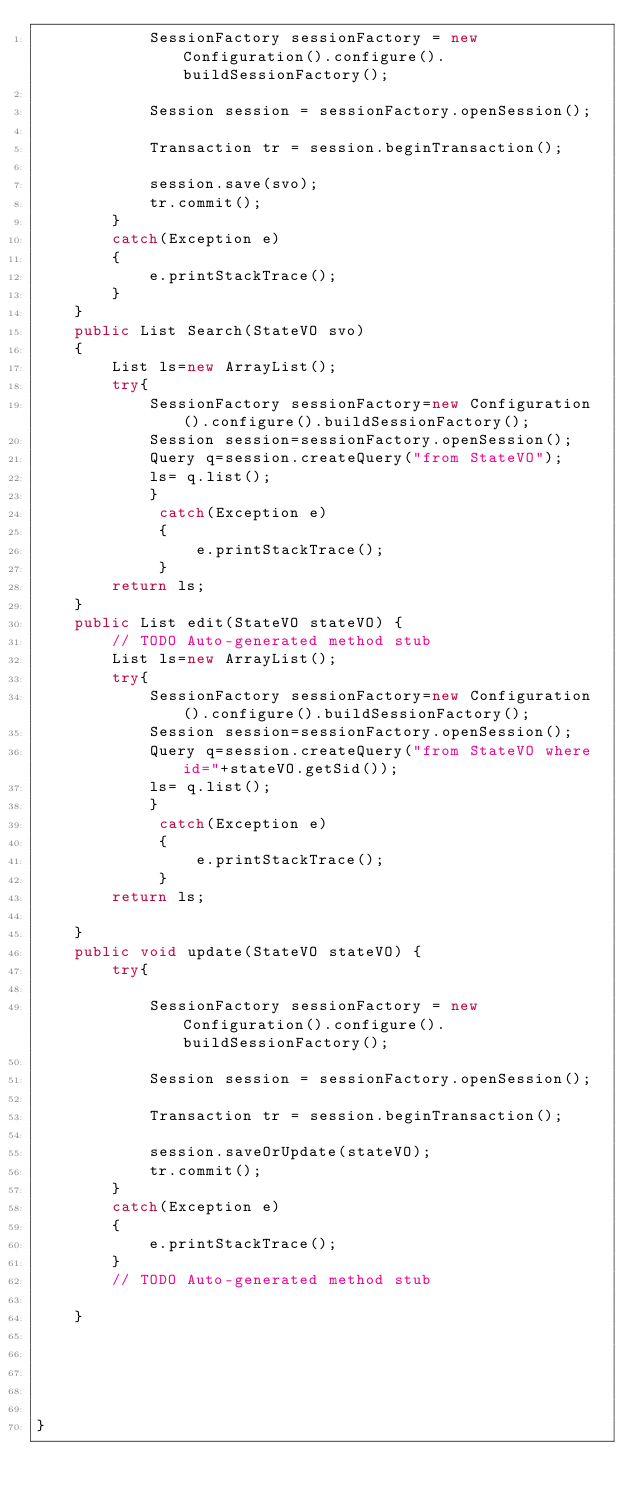Convert code to text. <code><loc_0><loc_0><loc_500><loc_500><_Java_>			SessionFactory sessionFactory = new Configuration().configure().buildSessionFactory();

			Session session = sessionFactory.openSession();

			Transaction tr = session.beginTransaction();

			session.save(svo);
			tr.commit();
		}
		catch(Exception e)
		{
			e.printStackTrace();
		}
	}
	public List Search(StateVO svo)
	{
		List ls=new ArrayList();
		try{
			SessionFactory sessionFactory=new Configuration().configure().buildSessionFactory();
			Session session=sessionFactory.openSession();
		    Query q=session.createQuery("from StateVO");
		    ls= q.list();
			}
		     catch(Exception e)
		     {
			     e.printStackTrace();
		     }
		return ls;
	}
	public List edit(StateVO stateVO) {
		// TODO Auto-generated method stub
		List ls=new ArrayList();
		try{
			SessionFactory sessionFactory=new Configuration().configure().buildSessionFactory();
			Session session=sessionFactory.openSession();
		    Query q=session.createQuery("from StateVO where id="+stateVO.getSid());
		    ls= q.list();
			}
		     catch(Exception e)
		     {
			     e.printStackTrace();
		     }
		return ls;
	
	}
	public void update(StateVO stateVO) {
		try{

			SessionFactory sessionFactory = new Configuration().configure().buildSessionFactory();

			Session session = sessionFactory.openSession();

			Transaction tr = session.beginTransaction();

			session.saveOrUpdate(stateVO);
			tr.commit();
		}
		catch(Exception e)
		{
			e.printStackTrace();
		}
		// TODO Auto-generated method stub
		
	}
	
	
	


}
</code> 